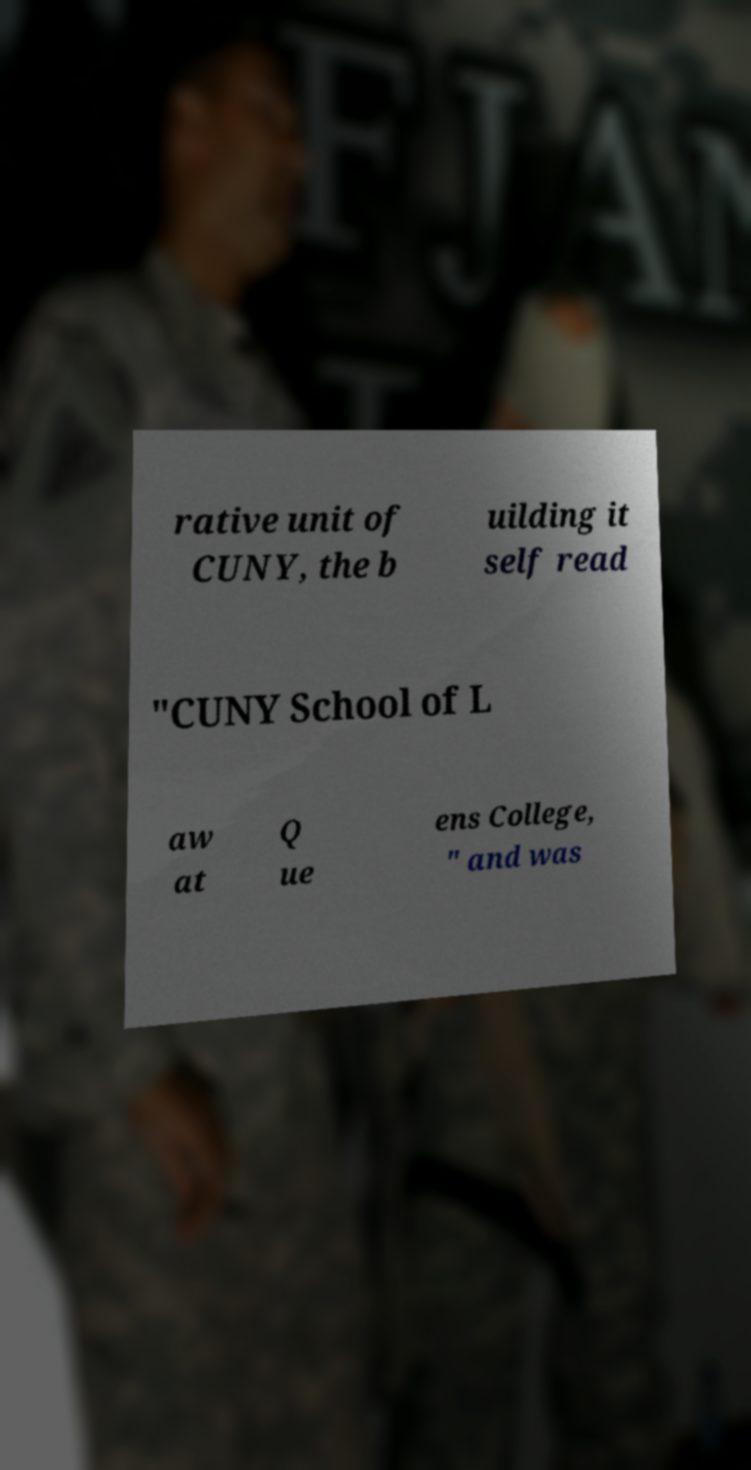Please identify and transcribe the text found in this image. rative unit of CUNY, the b uilding it self read "CUNY School of L aw at Q ue ens College, " and was 